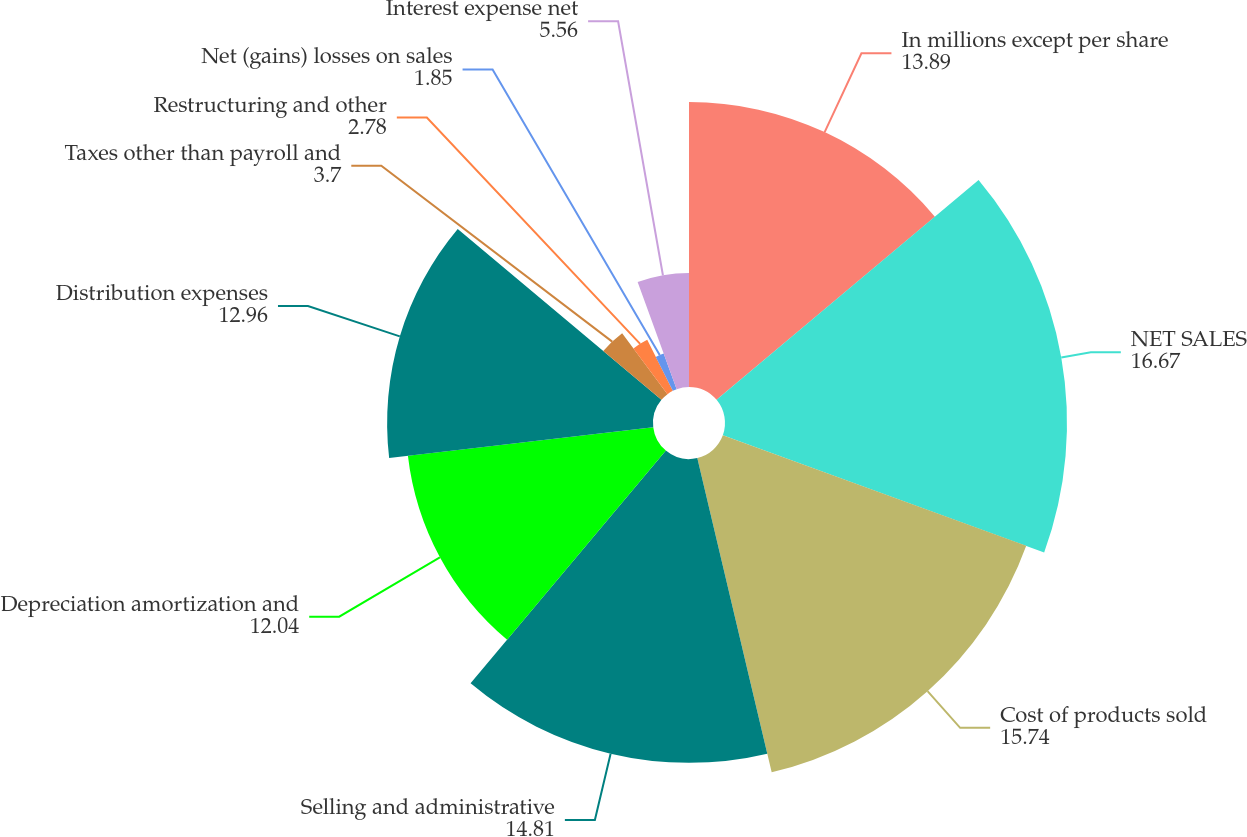Convert chart. <chart><loc_0><loc_0><loc_500><loc_500><pie_chart><fcel>In millions except per share<fcel>NET SALES<fcel>Cost of products sold<fcel>Selling and administrative<fcel>Depreciation amortization and<fcel>Distribution expenses<fcel>Taxes other than payroll and<fcel>Restructuring and other<fcel>Net (gains) losses on sales<fcel>Interest expense net<nl><fcel>13.89%<fcel>16.67%<fcel>15.74%<fcel>14.81%<fcel>12.04%<fcel>12.96%<fcel>3.7%<fcel>2.78%<fcel>1.85%<fcel>5.56%<nl></chart> 